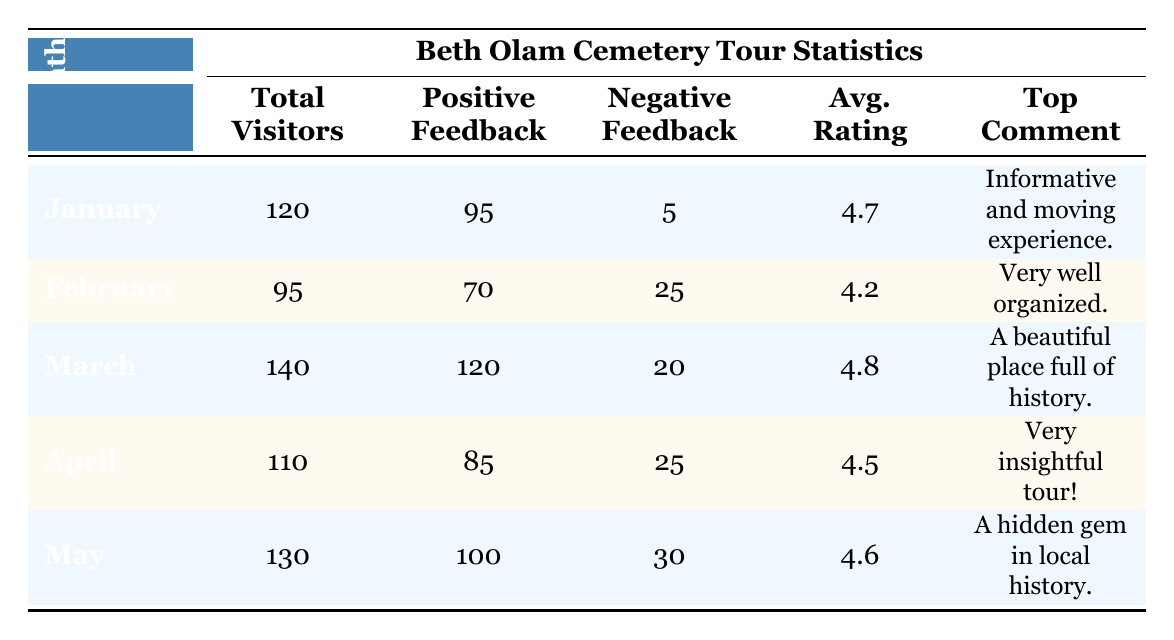What was the total number of visitors in March? The table states that in March, the total number of visitors was listed in the "Total Visitors" column as 140.
Answer: 140 Which month had the highest average rating for tours? Looking across the "Avg. Rating" column, March has the highest rating with 4.8 compared to other months.
Answer: March How many positive feedback responses were received in April? The "Positive Feedback" column for April shows a value of 85, indicating how many positive responses were collected.
Answer: 85 What was the overall number of negative feedback responses across all months? To find the total negative feedback, I sum the negative feedback values from each month: 5 (Jan) + 25 (Feb) + 20 (Mar) + 25 (Apr) + 30 (May) = 105.
Answer: 105 Did February have more negative feedback than positive feedback? In February, the "Negative Feedback" value is 25 while "Positive Feedback" is 70. Since 25 is less than 70, the statement is false.
Answer: No What was the average number of total visitors for all the months listed? I add the total visitors from all months: 120 (Jan) + 95 (Feb) + 140 (Mar) + 110 (Apr) + 130 (May) = 695, then divide by 5 months to get the average: 695/5 = 139.
Answer: 139 Which month had the most comments listed? Each month had three comments listed, making the number of comments equal across all periods.
Answer: All months are equal What can be said about the relationship between total visitors and average rating? In general, as observed, higher total visitor counts correlate with higher average ratings; for instance, March has the highest visitors and the highest rating.
Answer: Higher visitors tend to relate to higher ratings Did more than half of the visitors in May provide positive feedback? In May, there were 130 total visitors and 100 provided positive feedback. Since 100 is more than half of 130, the statement is true.
Answer: Yes 